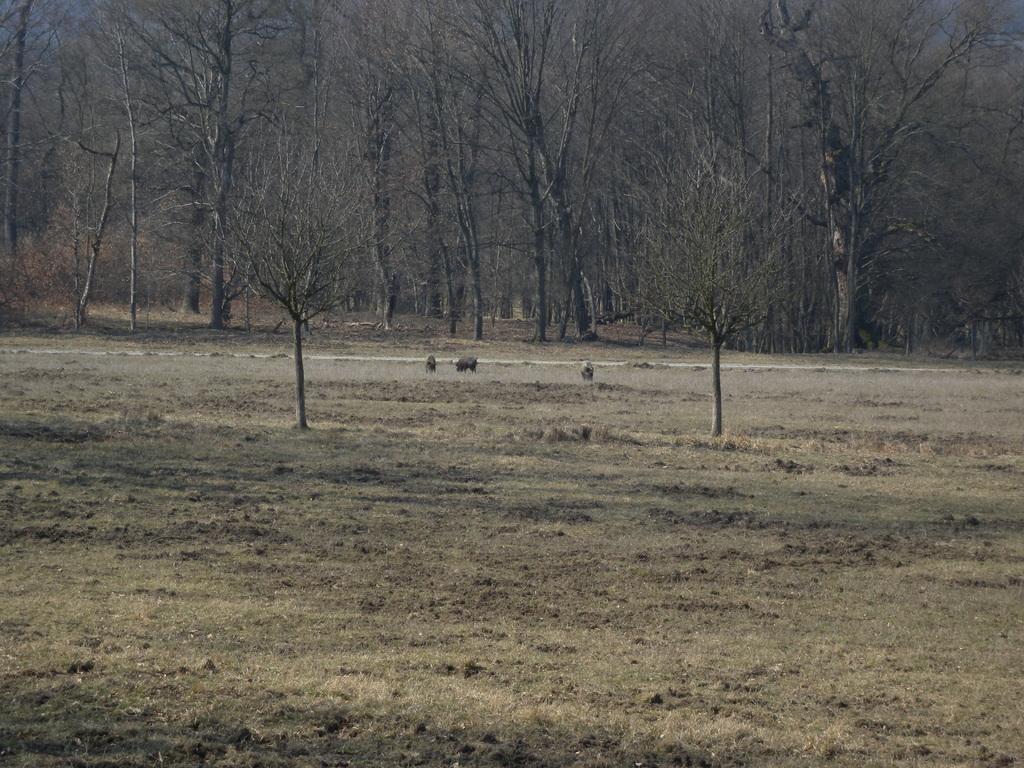Describe this image in one or two sentences. There is empty land in the foreground area of the image and trees in the background. 